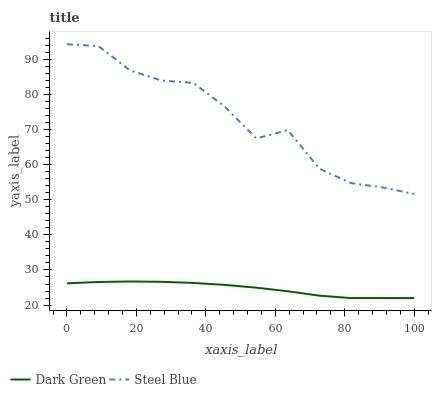Does Dark Green have the minimum area under the curve?
Answer yes or no. Yes. Does Steel Blue have the maximum area under the curve?
Answer yes or no. Yes. Does Dark Green have the maximum area under the curve?
Answer yes or no. No. Is Dark Green the smoothest?
Answer yes or no. Yes. Is Steel Blue the roughest?
Answer yes or no. Yes. Is Dark Green the roughest?
Answer yes or no. No. Does Steel Blue have the highest value?
Answer yes or no. Yes. Does Dark Green have the highest value?
Answer yes or no. No. Is Dark Green less than Steel Blue?
Answer yes or no. Yes. Is Steel Blue greater than Dark Green?
Answer yes or no. Yes. Does Dark Green intersect Steel Blue?
Answer yes or no. No. 